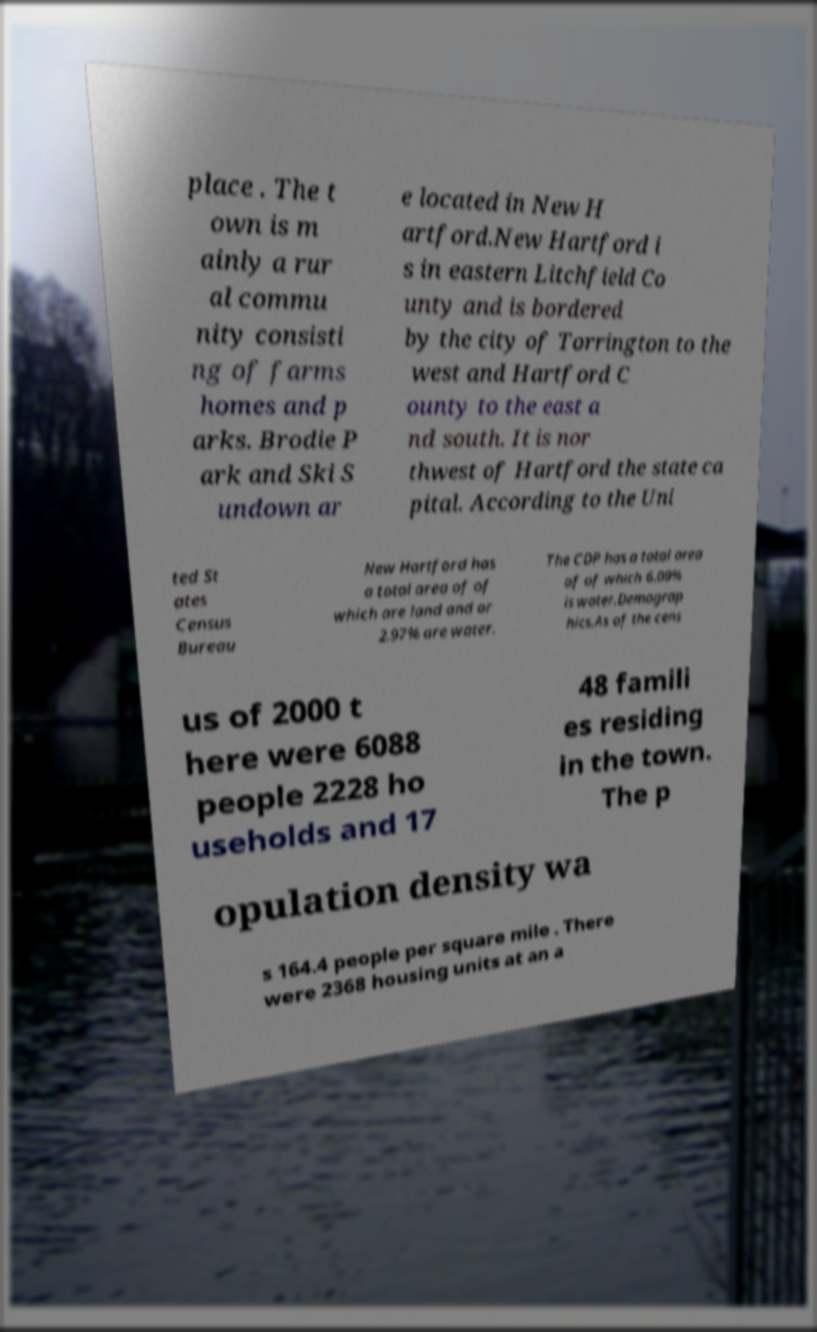Please read and relay the text visible in this image. What does it say? place . The t own is m ainly a rur al commu nity consisti ng of farms homes and p arks. Brodie P ark and Ski S undown ar e located in New H artford.New Hartford i s in eastern Litchfield Co unty and is bordered by the city of Torrington to the west and Hartford C ounty to the east a nd south. It is nor thwest of Hartford the state ca pital. According to the Uni ted St ates Census Bureau New Hartford has a total area of of which are land and or 2.97% are water. The CDP has a total area of of which 6.09% is water.Demograp hics.As of the cens us of 2000 t here were 6088 people 2228 ho useholds and 17 48 famili es residing in the town. The p opulation density wa s 164.4 people per square mile . There were 2368 housing units at an a 